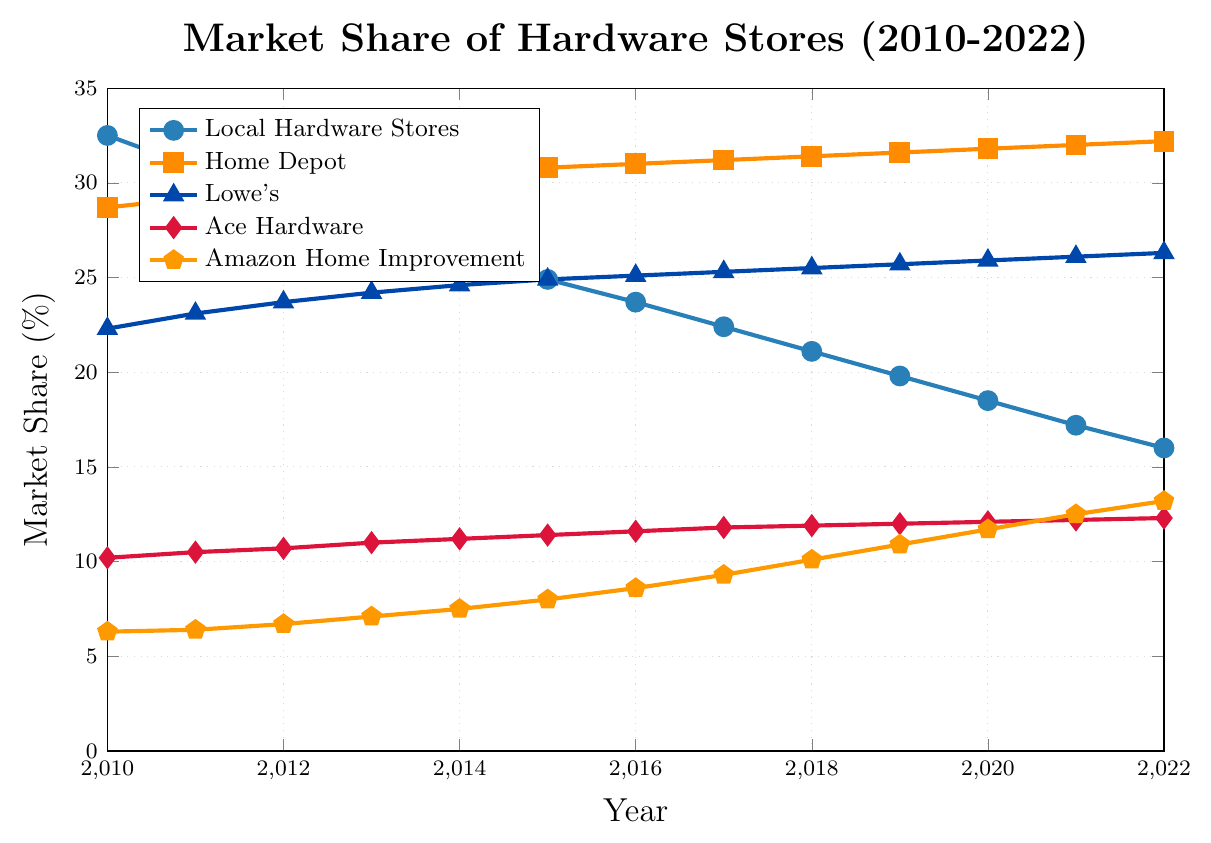What trend do you see in the market share of local hardware stores from 2010 to 2022? The market share of local hardware stores shows a consistent decline over the years. It starts at 32.5% in 2010 and decreases to 16.0% by 2022.
Answer: Declining Which store shows the greatest increase in market share over the period 2010 to 2022? To determine this, compare the increase in market share for each store: Home Depot increased from 28.7% to 32.2% (+3.5%), Lowe's increased from 22.3% to 26.3% (+4%), Ace Hardware increased from 10.2% to 12.3% (+2.1%), and Amazon Home Improvement increased from 6.3% to 13.2% (+6.9%). Amazon Home Improvement shows the greatest increase.
Answer: Amazon Home Improvement What is the combined market share of Home Depot and Amazon Home Improvement in 2022? The market share of Home Depot in 2022 is 32.2% and that of Amazon Home Improvement is 13.2%. Adding these together, 32.2% + 13.2% equals 45.4%.
Answer: 45.4% How does the market share of Ace Hardware in 2010 compare to its market share in 2022? The market share of Ace Hardware in 2010 was 10.2%, and by 2022, it increased to 12.3%. The market share has increased over this period.
Answer: Increased By how many percentage points did the market share of local hardware stores decrease from 2010 to 2022? The market share of local hardware stores decreased from 32.5% in 2010 to 16.0% in 2022. Subtracting 16.0 from 32.5 gives a decrease of 16.5 percentage points.
Answer: 16.5 Which retailer had the most stable market share throughout the years? To determine stability, observe the relative steadiness of the market share lines for each retailer. Home Depot's market share showed the least fluctuation, with values gradually increasing from 28.7% to 32.2%.
Answer: Home Depot What does the visual trend suggest about the impact of online sales on local hardware stores? The visual trend shows that as the market share of Amazon Home Improvement (an online retailer) consistently increases from 2010 to 2022, the market share of local hardware stores consistently decreases over the same period. This suggests a negative impact of online sales on local hardware stores.
Answer: Negative impact What is the rate of change in the market share of Amazon Home Improvement from 2010 to 2022? The market share of Amazon Home Improvement increased from 6.3% in 2010 to 13.2% in 2022. The rate of change can be calculated as (13.2 - 6.3) / 6.3 = 6.9 / 6.3 ≈ 1.095, or approximately 109.5%.
Answer: Approximately 109.5% What is the average market share of local hardware stores over the period 2010 to 2022? To find the average, sum up the market shares of local hardware stores for each year and divide by the number of years: (32.5 + 30.8 + 29.1 + 27.6 + 26.2 + 24.9 + 23.7 + 22.4 + 21.1 + 19.8 + 18.5 + 17.2 + 16.0) / 13 ≈ 24.04%.
Answer: Approximately 24.04% Between 2015 and 2022, which retailer had the highest increase in market share percentage? Calculate the difference between each retailer's market share in 2022 and 2015. Home Depot (32.2 - 30.8 = 1.4), Lowe's (26.3 - 24.9 = 1.4), Ace Hardware (12.3 - 11.4 = 0.9), Amazon (13.2 - 8.0 = 5.2). Amazon had the highest increase in market share percentage.
Answer: Amazon 